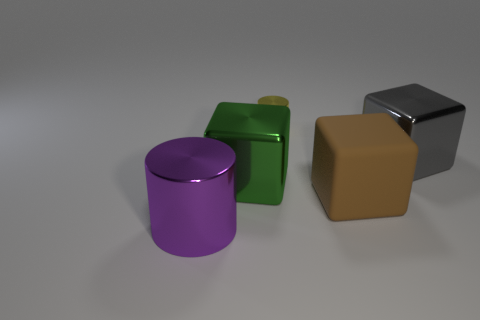Subtract all brown rubber cubes. How many cubes are left? 2 Subtract all gray cubes. How many cubes are left? 2 Add 2 gray metallic cubes. How many objects exist? 7 Subtract all blocks. How many objects are left? 2 Subtract 1 cubes. How many cubes are left? 2 Add 2 big cyan matte objects. How many big cyan matte objects exist? 2 Subtract 0 purple blocks. How many objects are left? 5 Subtract all yellow cylinders. Subtract all brown blocks. How many cylinders are left? 1 Subtract all large metal blocks. Subtract all small yellow cylinders. How many objects are left? 2 Add 4 brown things. How many brown things are left? 5 